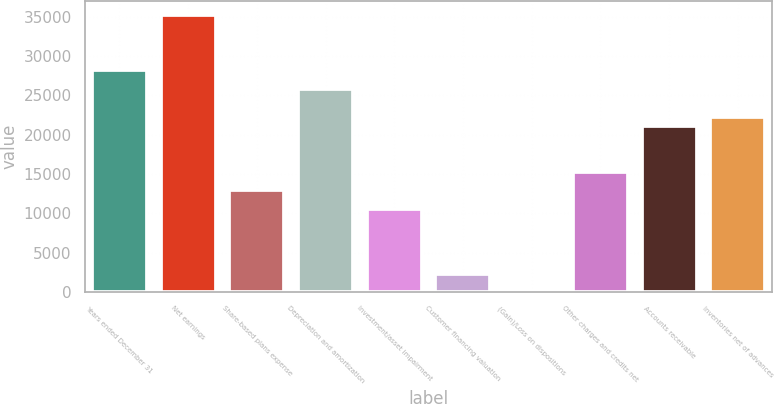Convert chart to OTSL. <chart><loc_0><loc_0><loc_500><loc_500><bar_chart><fcel>Years ended December 31<fcel>Net earnings<fcel>Share-based plans expense<fcel>Depreciation and amortization<fcel>Investment/asset impairment<fcel>Customer financing valuation<fcel>(Gain)/Loss on dispositions<fcel>Other charges and credits net<fcel>Accounts receivable<fcel>Inventories net of advances<nl><fcel>28157.8<fcel>35197<fcel>12906.2<fcel>25811.4<fcel>10559.8<fcel>2347.4<fcel>1<fcel>15252.6<fcel>21118.6<fcel>22291.8<nl></chart> 